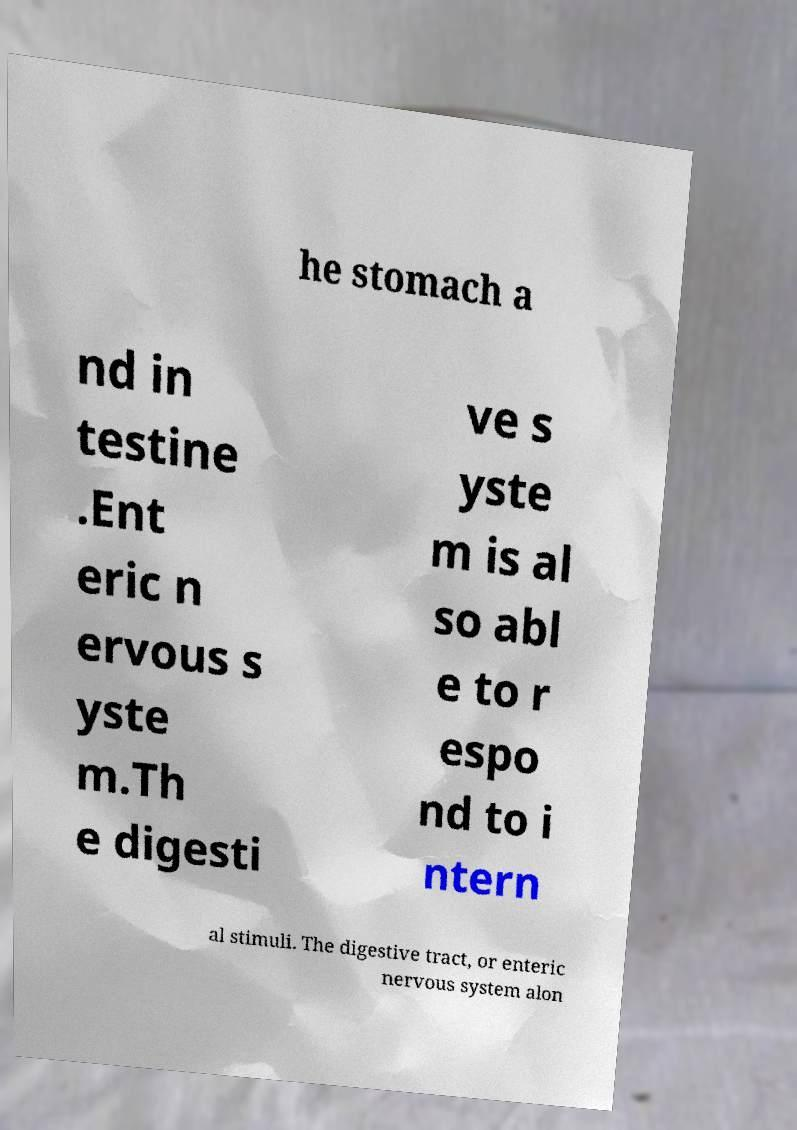Can you read and provide the text displayed in the image?This photo seems to have some interesting text. Can you extract and type it out for me? he stomach a nd in testine .Ent eric n ervous s yste m.Th e digesti ve s yste m is al so abl e to r espo nd to i ntern al stimuli. The digestive tract, or enteric nervous system alon 